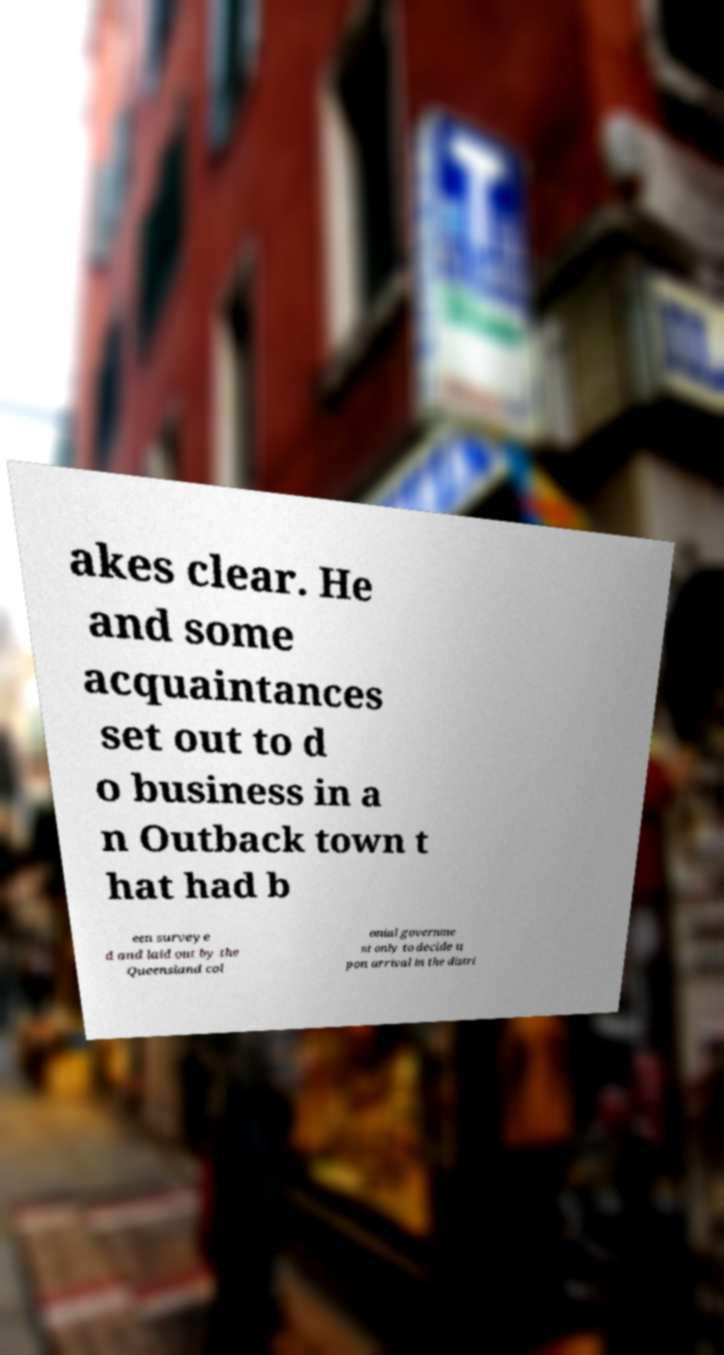Can you read and provide the text displayed in the image?This photo seems to have some interesting text. Can you extract and type it out for me? akes clear. He and some acquaintances set out to d o business in a n Outback town t hat had b een surveye d and laid out by the Queensland col onial governme nt only to decide u pon arrival in the distri 